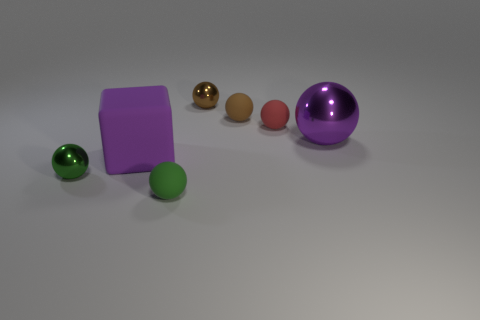Subtract all brown balls. How many balls are left? 4 Subtract all brown metallic balls. How many balls are left? 5 Subtract all purple spheres. Subtract all blue cylinders. How many spheres are left? 5 Add 3 big yellow metal things. How many objects exist? 10 Subtract all blocks. How many objects are left? 6 Add 4 blue shiny things. How many blue shiny things exist? 4 Subtract 0 yellow balls. How many objects are left? 7 Subtract all yellow metal cylinders. Subtract all big purple shiny things. How many objects are left? 6 Add 6 small matte objects. How many small matte objects are left? 9 